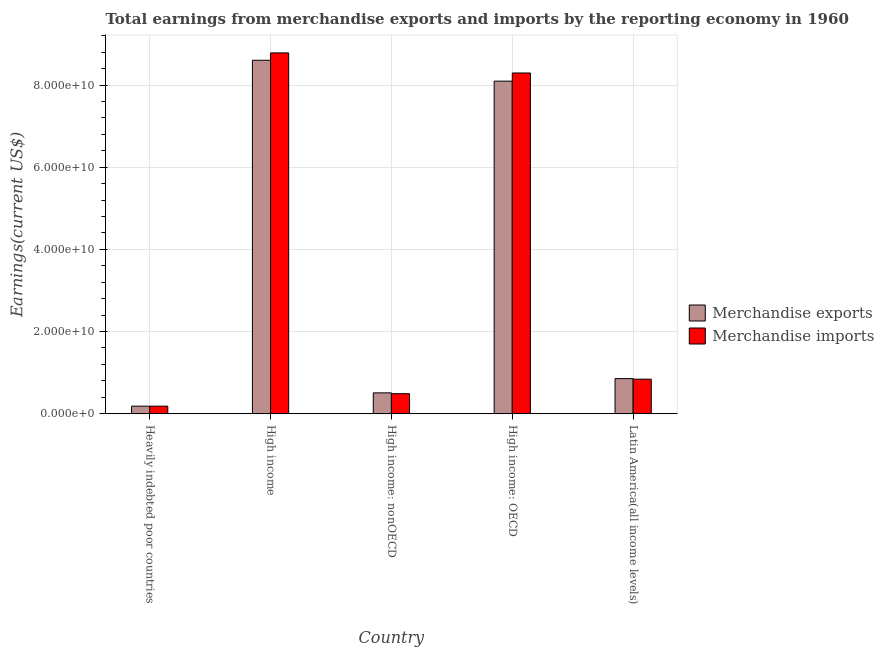How many different coloured bars are there?
Provide a short and direct response. 2. How many groups of bars are there?
Keep it short and to the point. 5. Are the number of bars per tick equal to the number of legend labels?
Make the answer very short. Yes. How many bars are there on the 4th tick from the right?
Provide a succinct answer. 2. What is the label of the 2nd group of bars from the left?
Ensure brevity in your answer.  High income. In how many cases, is the number of bars for a given country not equal to the number of legend labels?
Your answer should be very brief. 0. What is the earnings from merchandise exports in High income: nonOECD?
Provide a short and direct response. 5.08e+09. Across all countries, what is the maximum earnings from merchandise imports?
Ensure brevity in your answer.  8.78e+1. Across all countries, what is the minimum earnings from merchandise imports?
Your answer should be very brief. 1.84e+09. In which country was the earnings from merchandise exports maximum?
Keep it short and to the point. High income. In which country was the earnings from merchandise imports minimum?
Provide a succinct answer. Heavily indebted poor countries. What is the total earnings from merchandise exports in the graph?
Offer a very short reply. 1.82e+11. What is the difference between the earnings from merchandise exports in Heavily indebted poor countries and that in Latin America(all income levels)?
Provide a short and direct response. -6.71e+09. What is the difference between the earnings from merchandise exports in High income: nonOECD and the earnings from merchandise imports in High income?
Offer a terse response. -8.27e+1. What is the average earnings from merchandise imports per country?
Your response must be concise. 3.72e+1. What is the difference between the earnings from merchandise exports and earnings from merchandise imports in High income: OECD?
Provide a short and direct response. -1.98e+09. In how many countries, is the earnings from merchandise exports greater than 60000000000 US$?
Keep it short and to the point. 2. What is the ratio of the earnings from merchandise exports in Heavily indebted poor countries to that in High income?
Your response must be concise. 0.02. What is the difference between the highest and the second highest earnings from merchandise exports?
Your response must be concise. 5.08e+09. What is the difference between the highest and the lowest earnings from merchandise imports?
Your answer should be very brief. 8.60e+1. Are all the bars in the graph horizontal?
Offer a very short reply. No. Are the values on the major ticks of Y-axis written in scientific E-notation?
Ensure brevity in your answer.  Yes. Does the graph contain any zero values?
Ensure brevity in your answer.  No. What is the title of the graph?
Give a very brief answer. Total earnings from merchandise exports and imports by the reporting economy in 1960. Does "Domestic liabilities" appear as one of the legend labels in the graph?
Provide a succinct answer. No. What is the label or title of the X-axis?
Make the answer very short. Country. What is the label or title of the Y-axis?
Keep it short and to the point. Earnings(current US$). What is the Earnings(current US$) in Merchandise exports in Heavily indebted poor countries?
Provide a succinct answer. 1.85e+09. What is the Earnings(current US$) in Merchandise imports in Heavily indebted poor countries?
Make the answer very short. 1.84e+09. What is the Earnings(current US$) in Merchandise exports in High income?
Offer a very short reply. 8.60e+1. What is the Earnings(current US$) in Merchandise imports in High income?
Offer a terse response. 8.78e+1. What is the Earnings(current US$) in Merchandise exports in High income: nonOECD?
Offer a very short reply. 5.08e+09. What is the Earnings(current US$) in Merchandise imports in High income: nonOECD?
Provide a succinct answer. 4.88e+09. What is the Earnings(current US$) of Merchandise exports in High income: OECD?
Ensure brevity in your answer.  8.09e+1. What is the Earnings(current US$) in Merchandise imports in High income: OECD?
Your answer should be very brief. 8.29e+1. What is the Earnings(current US$) in Merchandise exports in Latin America(all income levels)?
Make the answer very short. 8.55e+09. What is the Earnings(current US$) in Merchandise imports in Latin America(all income levels)?
Keep it short and to the point. 8.41e+09. Across all countries, what is the maximum Earnings(current US$) in Merchandise exports?
Provide a short and direct response. 8.60e+1. Across all countries, what is the maximum Earnings(current US$) of Merchandise imports?
Keep it short and to the point. 8.78e+1. Across all countries, what is the minimum Earnings(current US$) in Merchandise exports?
Offer a terse response. 1.85e+09. Across all countries, what is the minimum Earnings(current US$) of Merchandise imports?
Your answer should be very brief. 1.84e+09. What is the total Earnings(current US$) in Merchandise exports in the graph?
Give a very brief answer. 1.82e+11. What is the total Earnings(current US$) of Merchandise imports in the graph?
Give a very brief answer. 1.86e+11. What is the difference between the Earnings(current US$) in Merchandise exports in Heavily indebted poor countries and that in High income?
Provide a short and direct response. -8.42e+1. What is the difference between the Earnings(current US$) of Merchandise imports in Heavily indebted poor countries and that in High income?
Offer a very short reply. -8.60e+1. What is the difference between the Earnings(current US$) in Merchandise exports in Heavily indebted poor countries and that in High income: nonOECD?
Keep it short and to the point. -3.23e+09. What is the difference between the Earnings(current US$) of Merchandise imports in Heavily indebted poor countries and that in High income: nonOECD?
Make the answer very short. -3.04e+09. What is the difference between the Earnings(current US$) of Merchandise exports in Heavily indebted poor countries and that in High income: OECD?
Offer a terse response. -7.91e+1. What is the difference between the Earnings(current US$) of Merchandise imports in Heavily indebted poor countries and that in High income: OECD?
Your answer should be compact. -8.11e+1. What is the difference between the Earnings(current US$) in Merchandise exports in Heavily indebted poor countries and that in Latin America(all income levels)?
Your response must be concise. -6.71e+09. What is the difference between the Earnings(current US$) in Merchandise imports in Heavily indebted poor countries and that in Latin America(all income levels)?
Offer a terse response. -6.57e+09. What is the difference between the Earnings(current US$) of Merchandise exports in High income and that in High income: nonOECD?
Your answer should be compact. 8.09e+1. What is the difference between the Earnings(current US$) in Merchandise imports in High income and that in High income: nonOECD?
Provide a short and direct response. 8.29e+1. What is the difference between the Earnings(current US$) in Merchandise exports in High income and that in High income: OECD?
Offer a very short reply. 5.08e+09. What is the difference between the Earnings(current US$) in Merchandise imports in High income and that in High income: OECD?
Make the answer very short. 4.88e+09. What is the difference between the Earnings(current US$) in Merchandise exports in High income and that in Latin America(all income levels)?
Give a very brief answer. 7.75e+1. What is the difference between the Earnings(current US$) in Merchandise imports in High income and that in Latin America(all income levels)?
Your answer should be compact. 7.94e+1. What is the difference between the Earnings(current US$) in Merchandise exports in High income: nonOECD and that in High income: OECD?
Your answer should be compact. -7.59e+1. What is the difference between the Earnings(current US$) in Merchandise imports in High income: nonOECD and that in High income: OECD?
Your answer should be compact. -7.80e+1. What is the difference between the Earnings(current US$) in Merchandise exports in High income: nonOECD and that in Latin America(all income levels)?
Offer a very short reply. -3.47e+09. What is the difference between the Earnings(current US$) in Merchandise imports in High income: nonOECD and that in Latin America(all income levels)?
Offer a very short reply. -3.53e+09. What is the difference between the Earnings(current US$) of Merchandise exports in High income: OECD and that in Latin America(all income levels)?
Your answer should be very brief. 7.24e+1. What is the difference between the Earnings(current US$) in Merchandise imports in High income: OECD and that in Latin America(all income levels)?
Ensure brevity in your answer.  7.45e+1. What is the difference between the Earnings(current US$) of Merchandise exports in Heavily indebted poor countries and the Earnings(current US$) of Merchandise imports in High income?
Your answer should be compact. -8.60e+1. What is the difference between the Earnings(current US$) in Merchandise exports in Heavily indebted poor countries and the Earnings(current US$) in Merchandise imports in High income: nonOECD?
Offer a very short reply. -3.04e+09. What is the difference between the Earnings(current US$) of Merchandise exports in Heavily indebted poor countries and the Earnings(current US$) of Merchandise imports in High income: OECD?
Your answer should be compact. -8.11e+1. What is the difference between the Earnings(current US$) in Merchandise exports in Heavily indebted poor countries and the Earnings(current US$) in Merchandise imports in Latin America(all income levels)?
Provide a succinct answer. -6.57e+09. What is the difference between the Earnings(current US$) in Merchandise exports in High income and the Earnings(current US$) in Merchandise imports in High income: nonOECD?
Give a very brief answer. 8.11e+1. What is the difference between the Earnings(current US$) in Merchandise exports in High income and the Earnings(current US$) in Merchandise imports in High income: OECD?
Ensure brevity in your answer.  3.09e+09. What is the difference between the Earnings(current US$) of Merchandise exports in High income and the Earnings(current US$) of Merchandise imports in Latin America(all income levels)?
Keep it short and to the point. 7.76e+1. What is the difference between the Earnings(current US$) in Merchandise exports in High income: nonOECD and the Earnings(current US$) in Merchandise imports in High income: OECD?
Provide a short and direct response. -7.79e+1. What is the difference between the Earnings(current US$) in Merchandise exports in High income: nonOECD and the Earnings(current US$) in Merchandise imports in Latin America(all income levels)?
Provide a succinct answer. -3.33e+09. What is the difference between the Earnings(current US$) in Merchandise exports in High income: OECD and the Earnings(current US$) in Merchandise imports in Latin America(all income levels)?
Provide a succinct answer. 7.25e+1. What is the average Earnings(current US$) in Merchandise exports per country?
Your response must be concise. 3.65e+1. What is the average Earnings(current US$) of Merchandise imports per country?
Provide a succinct answer. 3.72e+1. What is the difference between the Earnings(current US$) of Merchandise exports and Earnings(current US$) of Merchandise imports in Heavily indebted poor countries?
Provide a short and direct response. 3.13e+06. What is the difference between the Earnings(current US$) of Merchandise exports and Earnings(current US$) of Merchandise imports in High income?
Provide a short and direct response. -1.79e+09. What is the difference between the Earnings(current US$) in Merchandise exports and Earnings(current US$) in Merchandise imports in High income: nonOECD?
Your response must be concise. 1.97e+08. What is the difference between the Earnings(current US$) of Merchandise exports and Earnings(current US$) of Merchandise imports in High income: OECD?
Make the answer very short. -1.98e+09. What is the difference between the Earnings(current US$) of Merchandise exports and Earnings(current US$) of Merchandise imports in Latin America(all income levels)?
Your answer should be compact. 1.39e+08. What is the ratio of the Earnings(current US$) of Merchandise exports in Heavily indebted poor countries to that in High income?
Offer a very short reply. 0.02. What is the ratio of the Earnings(current US$) in Merchandise imports in Heavily indebted poor countries to that in High income?
Keep it short and to the point. 0.02. What is the ratio of the Earnings(current US$) of Merchandise exports in Heavily indebted poor countries to that in High income: nonOECD?
Provide a short and direct response. 0.36. What is the ratio of the Earnings(current US$) of Merchandise imports in Heavily indebted poor countries to that in High income: nonOECD?
Offer a very short reply. 0.38. What is the ratio of the Earnings(current US$) in Merchandise exports in Heavily indebted poor countries to that in High income: OECD?
Your answer should be compact. 0.02. What is the ratio of the Earnings(current US$) in Merchandise imports in Heavily indebted poor countries to that in High income: OECD?
Your answer should be compact. 0.02. What is the ratio of the Earnings(current US$) in Merchandise exports in Heavily indebted poor countries to that in Latin America(all income levels)?
Provide a succinct answer. 0.22. What is the ratio of the Earnings(current US$) of Merchandise imports in Heavily indebted poor countries to that in Latin America(all income levels)?
Provide a short and direct response. 0.22. What is the ratio of the Earnings(current US$) of Merchandise exports in High income to that in High income: nonOECD?
Ensure brevity in your answer.  16.94. What is the ratio of the Earnings(current US$) in Merchandise imports in High income to that in High income: nonOECD?
Keep it short and to the point. 17.99. What is the ratio of the Earnings(current US$) in Merchandise exports in High income to that in High income: OECD?
Ensure brevity in your answer.  1.06. What is the ratio of the Earnings(current US$) of Merchandise imports in High income to that in High income: OECD?
Your answer should be very brief. 1.06. What is the ratio of the Earnings(current US$) in Merchandise exports in High income to that in Latin America(all income levels)?
Offer a terse response. 10.06. What is the ratio of the Earnings(current US$) in Merchandise imports in High income to that in Latin America(all income levels)?
Provide a short and direct response. 10.44. What is the ratio of the Earnings(current US$) in Merchandise exports in High income: nonOECD to that in High income: OECD?
Ensure brevity in your answer.  0.06. What is the ratio of the Earnings(current US$) in Merchandise imports in High income: nonOECD to that in High income: OECD?
Provide a succinct answer. 0.06. What is the ratio of the Earnings(current US$) of Merchandise exports in High income: nonOECD to that in Latin America(all income levels)?
Your answer should be very brief. 0.59. What is the ratio of the Earnings(current US$) of Merchandise imports in High income: nonOECD to that in Latin America(all income levels)?
Offer a very short reply. 0.58. What is the ratio of the Earnings(current US$) in Merchandise exports in High income: OECD to that in Latin America(all income levels)?
Make the answer very short. 9.47. What is the ratio of the Earnings(current US$) in Merchandise imports in High income: OECD to that in Latin America(all income levels)?
Keep it short and to the point. 9.86. What is the difference between the highest and the second highest Earnings(current US$) in Merchandise exports?
Provide a succinct answer. 5.08e+09. What is the difference between the highest and the second highest Earnings(current US$) of Merchandise imports?
Give a very brief answer. 4.88e+09. What is the difference between the highest and the lowest Earnings(current US$) in Merchandise exports?
Your answer should be very brief. 8.42e+1. What is the difference between the highest and the lowest Earnings(current US$) in Merchandise imports?
Offer a very short reply. 8.60e+1. 